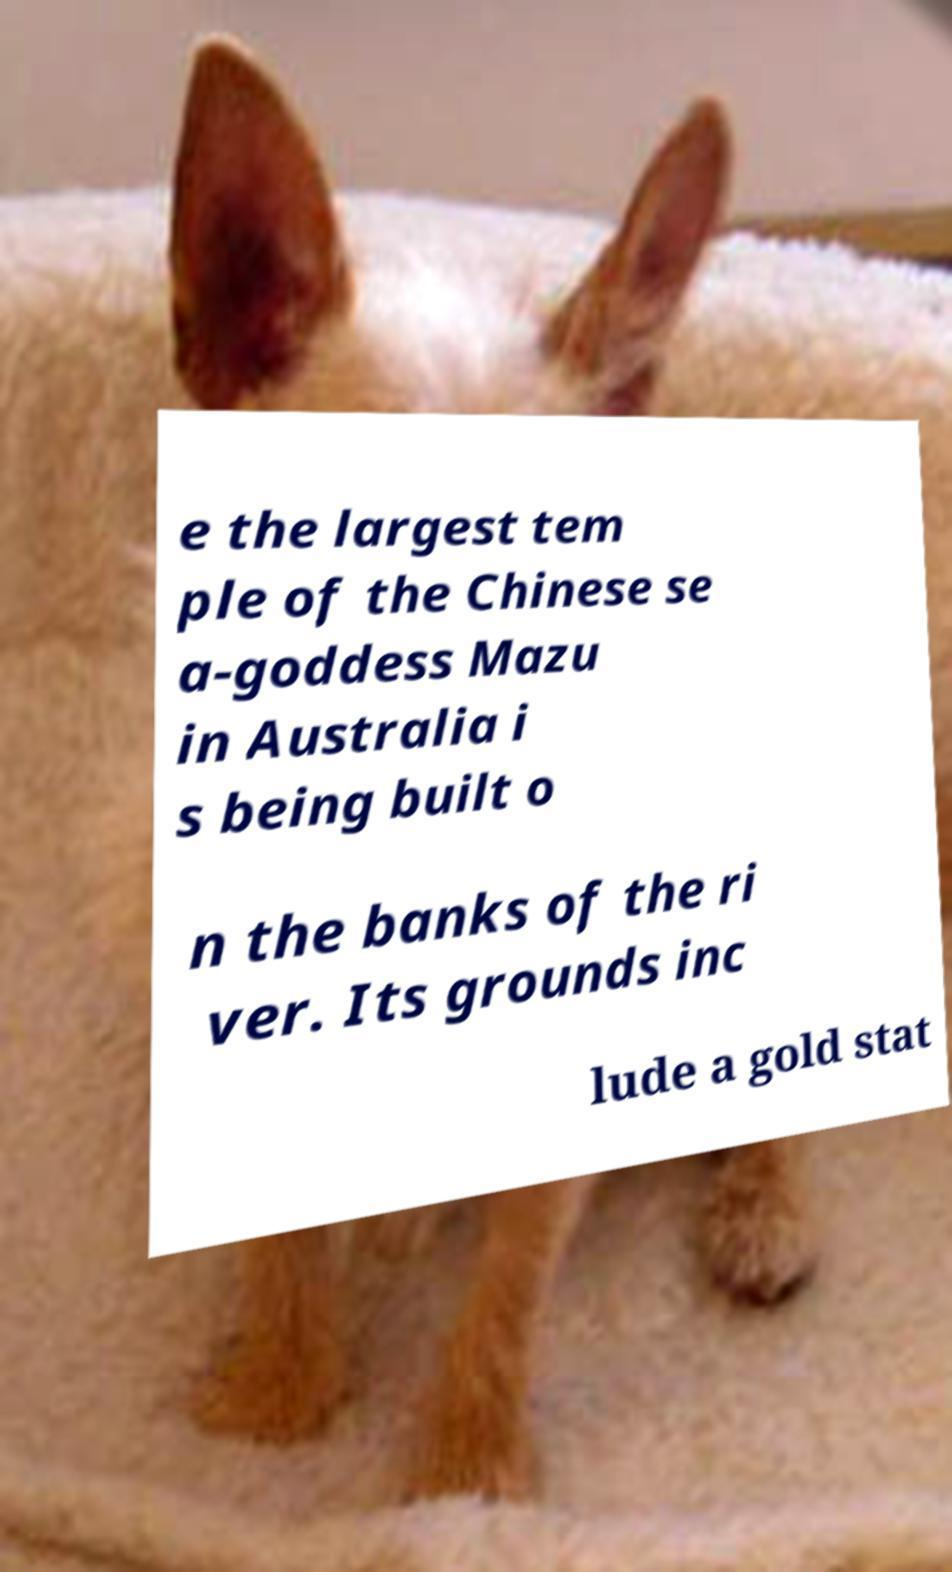Could you assist in decoding the text presented in this image and type it out clearly? e the largest tem ple of the Chinese se a-goddess Mazu in Australia i s being built o n the banks of the ri ver. Its grounds inc lude a gold stat 